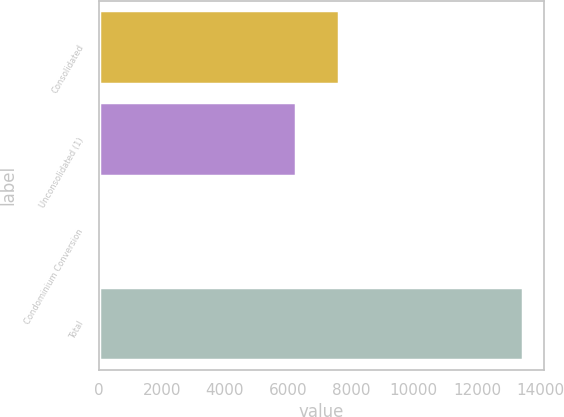<chart> <loc_0><loc_0><loc_500><loc_500><bar_chart><fcel>Consolidated<fcel>Unconsolidated (1)<fcel>Condominium Conversion<fcel>Total<nl><fcel>7619.6<fcel>6275<fcel>2<fcel>13448<nl></chart> 